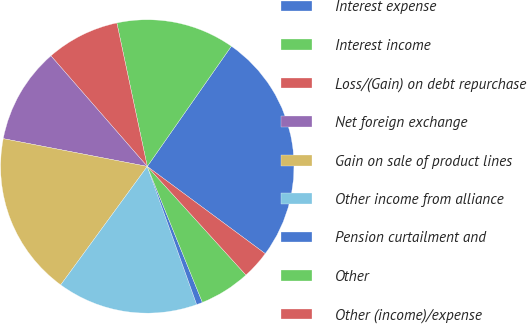Convert chart. <chart><loc_0><loc_0><loc_500><loc_500><pie_chart><fcel>Interest expense<fcel>Interest income<fcel>Loss/(Gain) on debt repurchase<fcel>Net foreign exchange<fcel>Gain on sale of product lines<fcel>Other income from alliance<fcel>Pension curtailment and<fcel>Other<fcel>Other (income)/expense<nl><fcel>25.42%<fcel>13.04%<fcel>8.08%<fcel>10.56%<fcel>17.99%<fcel>15.51%<fcel>0.66%<fcel>5.61%<fcel>3.13%<nl></chart> 